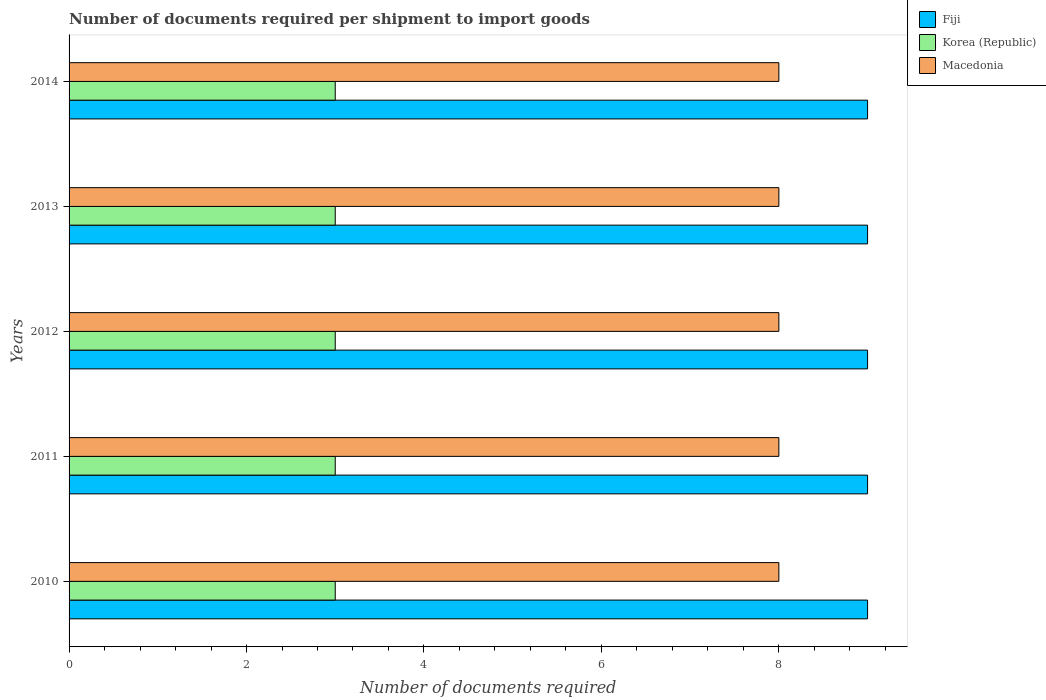How many different coloured bars are there?
Ensure brevity in your answer.  3. How many groups of bars are there?
Make the answer very short. 5. Are the number of bars per tick equal to the number of legend labels?
Your answer should be compact. Yes. Are the number of bars on each tick of the Y-axis equal?
Offer a terse response. Yes. How many bars are there on the 4th tick from the top?
Offer a terse response. 3. How many bars are there on the 2nd tick from the bottom?
Your answer should be compact. 3. In how many cases, is the number of bars for a given year not equal to the number of legend labels?
Your answer should be compact. 0. What is the number of documents required per shipment to import goods in Macedonia in 2013?
Provide a short and direct response. 8. Across all years, what is the maximum number of documents required per shipment to import goods in Fiji?
Offer a terse response. 9. Across all years, what is the minimum number of documents required per shipment to import goods in Macedonia?
Provide a short and direct response. 8. What is the total number of documents required per shipment to import goods in Korea (Republic) in the graph?
Provide a succinct answer. 15. What is the difference between the number of documents required per shipment to import goods in Macedonia in 2014 and the number of documents required per shipment to import goods in Korea (Republic) in 2012?
Ensure brevity in your answer.  5. In the year 2011, what is the difference between the number of documents required per shipment to import goods in Korea (Republic) and number of documents required per shipment to import goods in Fiji?
Your answer should be compact. -6. What is the ratio of the number of documents required per shipment to import goods in Fiji in 2012 to that in 2014?
Offer a terse response. 1. Is the number of documents required per shipment to import goods in Macedonia in 2010 less than that in 2014?
Offer a very short reply. No. Is the difference between the number of documents required per shipment to import goods in Korea (Republic) in 2013 and 2014 greater than the difference between the number of documents required per shipment to import goods in Fiji in 2013 and 2014?
Offer a very short reply. No. What is the difference between the highest and the second highest number of documents required per shipment to import goods in Macedonia?
Make the answer very short. 0. What is the difference between the highest and the lowest number of documents required per shipment to import goods in Macedonia?
Give a very brief answer. 0. In how many years, is the number of documents required per shipment to import goods in Korea (Republic) greater than the average number of documents required per shipment to import goods in Korea (Republic) taken over all years?
Provide a succinct answer. 0. What does the 3rd bar from the top in 2012 represents?
Ensure brevity in your answer.  Fiji. What does the 1st bar from the bottom in 2013 represents?
Provide a succinct answer. Fiji. How many bars are there?
Provide a succinct answer. 15. Are all the bars in the graph horizontal?
Keep it short and to the point. Yes. How many years are there in the graph?
Provide a succinct answer. 5. Are the values on the major ticks of X-axis written in scientific E-notation?
Ensure brevity in your answer.  No. Does the graph contain any zero values?
Provide a short and direct response. No. How many legend labels are there?
Offer a terse response. 3. What is the title of the graph?
Your answer should be compact. Number of documents required per shipment to import goods. Does "Faeroe Islands" appear as one of the legend labels in the graph?
Give a very brief answer. No. What is the label or title of the X-axis?
Make the answer very short. Number of documents required. What is the Number of documents required in Fiji in 2010?
Provide a succinct answer. 9. What is the Number of documents required in Korea (Republic) in 2010?
Your response must be concise. 3. What is the Number of documents required in Korea (Republic) in 2011?
Offer a very short reply. 3. What is the Number of documents required in Korea (Republic) in 2012?
Offer a very short reply. 3. What is the Number of documents required in Korea (Republic) in 2013?
Ensure brevity in your answer.  3. What is the Number of documents required of Fiji in 2014?
Offer a very short reply. 9. What is the Number of documents required in Korea (Republic) in 2014?
Give a very brief answer. 3. Across all years, what is the maximum Number of documents required in Macedonia?
Provide a short and direct response. 8. Across all years, what is the minimum Number of documents required in Fiji?
Your response must be concise. 9. What is the total Number of documents required of Fiji in the graph?
Ensure brevity in your answer.  45. What is the difference between the Number of documents required in Fiji in 2010 and that in 2011?
Give a very brief answer. 0. What is the difference between the Number of documents required of Fiji in 2010 and that in 2012?
Provide a short and direct response. 0. What is the difference between the Number of documents required in Korea (Republic) in 2010 and that in 2012?
Give a very brief answer. 0. What is the difference between the Number of documents required of Fiji in 2010 and that in 2013?
Offer a very short reply. 0. What is the difference between the Number of documents required in Macedonia in 2010 and that in 2013?
Provide a short and direct response. 0. What is the difference between the Number of documents required in Fiji in 2011 and that in 2013?
Ensure brevity in your answer.  0. What is the difference between the Number of documents required in Macedonia in 2011 and that in 2013?
Offer a terse response. 0. What is the difference between the Number of documents required of Fiji in 2013 and that in 2014?
Keep it short and to the point. 0. What is the difference between the Number of documents required in Fiji in 2010 and the Number of documents required in Macedonia in 2011?
Provide a short and direct response. 1. What is the difference between the Number of documents required of Korea (Republic) in 2010 and the Number of documents required of Macedonia in 2011?
Your answer should be very brief. -5. What is the difference between the Number of documents required of Fiji in 2010 and the Number of documents required of Macedonia in 2012?
Your response must be concise. 1. What is the difference between the Number of documents required of Korea (Republic) in 2010 and the Number of documents required of Macedonia in 2013?
Provide a short and direct response. -5. What is the difference between the Number of documents required of Fiji in 2010 and the Number of documents required of Korea (Republic) in 2014?
Provide a short and direct response. 6. What is the difference between the Number of documents required in Korea (Republic) in 2010 and the Number of documents required in Macedonia in 2014?
Your answer should be compact. -5. What is the difference between the Number of documents required of Fiji in 2011 and the Number of documents required of Korea (Republic) in 2013?
Ensure brevity in your answer.  6. What is the difference between the Number of documents required of Fiji in 2011 and the Number of documents required of Macedonia in 2013?
Your answer should be very brief. 1. What is the difference between the Number of documents required of Fiji in 2011 and the Number of documents required of Macedonia in 2014?
Offer a terse response. 1. What is the difference between the Number of documents required of Korea (Republic) in 2011 and the Number of documents required of Macedonia in 2014?
Your response must be concise. -5. What is the difference between the Number of documents required in Fiji in 2012 and the Number of documents required in Korea (Republic) in 2013?
Offer a very short reply. 6. What is the difference between the Number of documents required in Korea (Republic) in 2012 and the Number of documents required in Macedonia in 2014?
Give a very brief answer. -5. What is the difference between the Number of documents required in Fiji in 2013 and the Number of documents required in Macedonia in 2014?
Offer a terse response. 1. What is the difference between the Number of documents required in Korea (Republic) in 2013 and the Number of documents required in Macedonia in 2014?
Keep it short and to the point. -5. What is the average Number of documents required of Korea (Republic) per year?
Offer a very short reply. 3. What is the average Number of documents required of Macedonia per year?
Provide a succinct answer. 8. In the year 2011, what is the difference between the Number of documents required in Fiji and Number of documents required in Korea (Republic)?
Keep it short and to the point. 6. In the year 2011, what is the difference between the Number of documents required of Fiji and Number of documents required of Macedonia?
Keep it short and to the point. 1. In the year 2012, what is the difference between the Number of documents required in Korea (Republic) and Number of documents required in Macedonia?
Give a very brief answer. -5. In the year 2013, what is the difference between the Number of documents required of Fiji and Number of documents required of Korea (Republic)?
Keep it short and to the point. 6. In the year 2013, what is the difference between the Number of documents required in Fiji and Number of documents required in Macedonia?
Offer a terse response. 1. In the year 2013, what is the difference between the Number of documents required of Korea (Republic) and Number of documents required of Macedonia?
Your answer should be very brief. -5. In the year 2014, what is the difference between the Number of documents required in Fiji and Number of documents required in Macedonia?
Your answer should be compact. 1. In the year 2014, what is the difference between the Number of documents required in Korea (Republic) and Number of documents required in Macedonia?
Provide a succinct answer. -5. What is the ratio of the Number of documents required in Fiji in 2010 to that in 2011?
Offer a terse response. 1. What is the ratio of the Number of documents required of Korea (Republic) in 2010 to that in 2012?
Your response must be concise. 1. What is the ratio of the Number of documents required of Macedonia in 2010 to that in 2012?
Your response must be concise. 1. What is the ratio of the Number of documents required in Fiji in 2010 to that in 2013?
Make the answer very short. 1. What is the ratio of the Number of documents required of Macedonia in 2010 to that in 2013?
Give a very brief answer. 1. What is the ratio of the Number of documents required of Fiji in 2010 to that in 2014?
Ensure brevity in your answer.  1. What is the ratio of the Number of documents required in Korea (Republic) in 2010 to that in 2014?
Offer a very short reply. 1. What is the ratio of the Number of documents required of Fiji in 2011 to that in 2012?
Your answer should be very brief. 1. What is the ratio of the Number of documents required in Korea (Republic) in 2011 to that in 2013?
Your answer should be compact. 1. What is the ratio of the Number of documents required in Fiji in 2011 to that in 2014?
Provide a succinct answer. 1. What is the ratio of the Number of documents required in Korea (Republic) in 2011 to that in 2014?
Your response must be concise. 1. What is the ratio of the Number of documents required of Macedonia in 2011 to that in 2014?
Ensure brevity in your answer.  1. What is the ratio of the Number of documents required of Korea (Republic) in 2012 to that in 2013?
Your answer should be very brief. 1. What is the ratio of the Number of documents required in Macedonia in 2012 to that in 2014?
Offer a terse response. 1. What is the ratio of the Number of documents required of Korea (Republic) in 2013 to that in 2014?
Your answer should be very brief. 1. What is the ratio of the Number of documents required in Macedonia in 2013 to that in 2014?
Ensure brevity in your answer.  1. What is the difference between the highest and the second highest Number of documents required of Fiji?
Keep it short and to the point. 0. What is the difference between the highest and the lowest Number of documents required of Fiji?
Your response must be concise. 0. What is the difference between the highest and the lowest Number of documents required of Korea (Republic)?
Make the answer very short. 0. What is the difference between the highest and the lowest Number of documents required of Macedonia?
Keep it short and to the point. 0. 